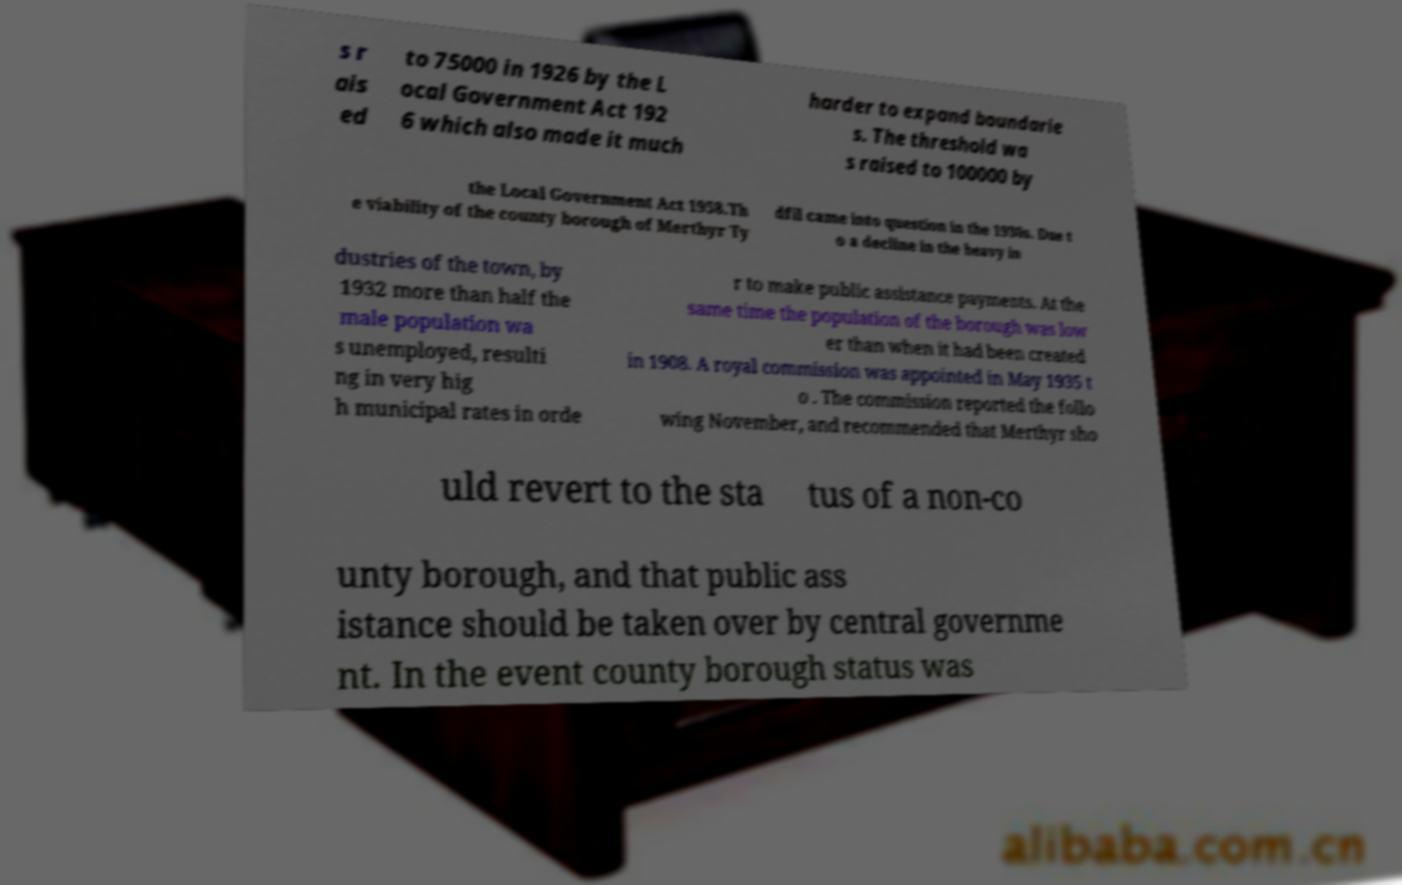There's text embedded in this image that I need extracted. Can you transcribe it verbatim? s r ais ed to 75000 in 1926 by the L ocal Government Act 192 6 which also made it much harder to expand boundarie s. The threshold wa s raised to 100000 by the Local Government Act 1958.Th e viability of the county borough of Merthyr Ty dfil came into question in the 1930s. Due t o a decline in the heavy in dustries of the town, by 1932 more than half the male population wa s unemployed, resulti ng in very hig h municipal rates in orde r to make public assistance payments. At the same time the population of the borough was low er than when it had been created in 1908. A royal commission was appointed in May 1935 t o . The commission reported the follo wing November, and recommended that Merthyr sho uld revert to the sta tus of a non-co unty borough, and that public ass istance should be taken over by central governme nt. In the event county borough status was 